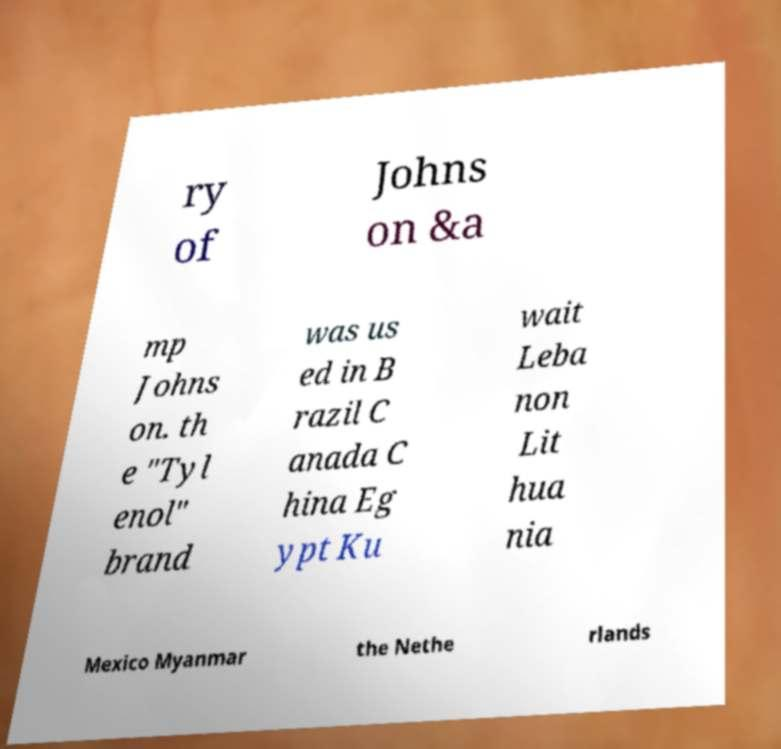Please identify and transcribe the text found in this image. ry of Johns on &a mp Johns on. th e "Tyl enol" brand was us ed in B razil C anada C hina Eg ypt Ku wait Leba non Lit hua nia Mexico Myanmar the Nethe rlands 